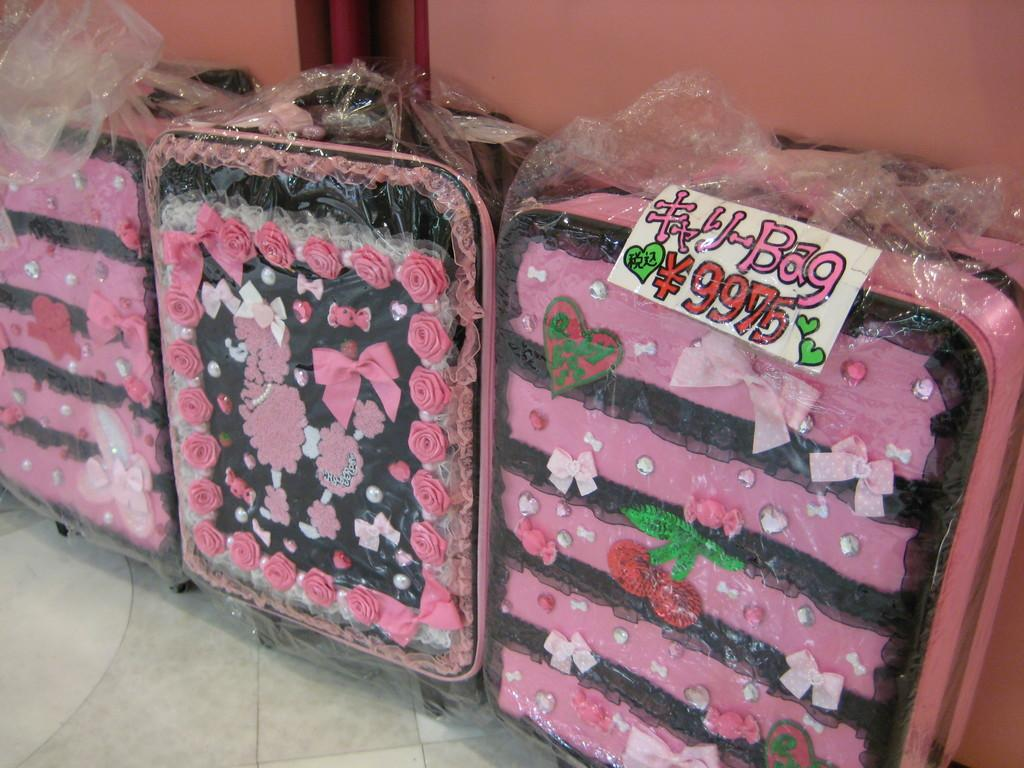What can be seen in the background of the image? There is a wall in the background of the image. What objects are on the floor in the image? There are luggage bags on the floor. How are the luggage bags decorated? The luggage bags are decorated with pink flowers and ribbons. Can you see the toes of the person holding the luggage bags in the image? There is no person holding the luggage bags in the image, so it is not possible to see their toes. Is there a rabbit visible in the image? There is no rabbit present in the image. 